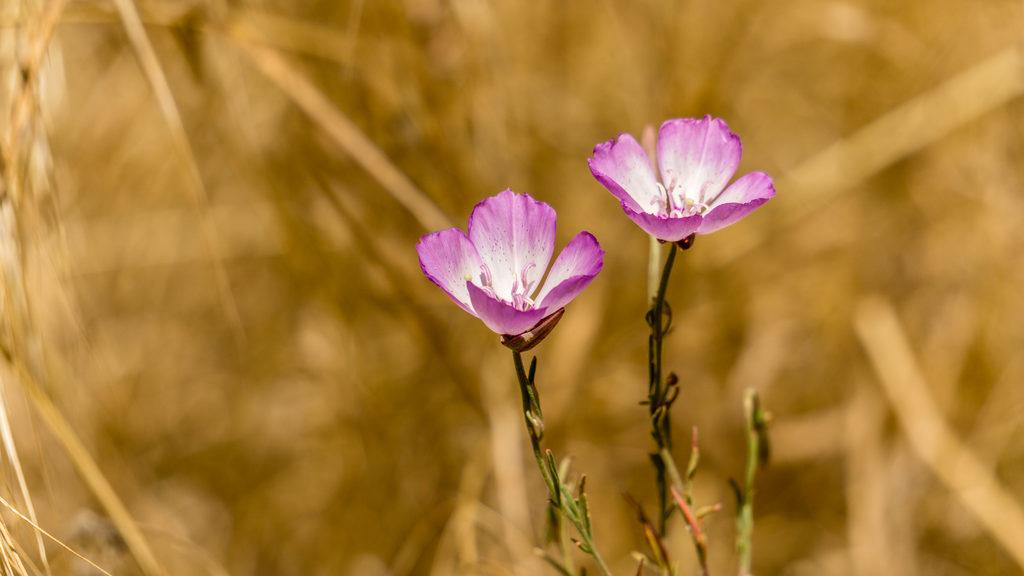What is the main subject of the image? The main subject of the image is flowers and plants. Where are the flowers and plants located in the image? The flowers and plants are in the center of the image. Can you describe the background of the image? The background of the image is blurry. How many ducks are visible on the sidewalk in the image? There are no ducks or sidewalks present in the image; it features flowers and plants with a blurry background. 